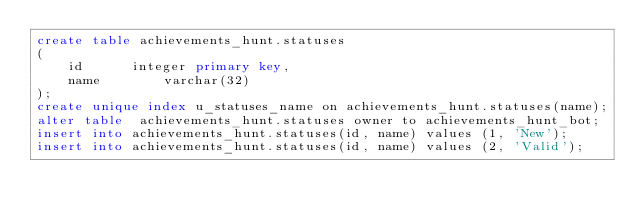<code> <loc_0><loc_0><loc_500><loc_500><_SQL_>create table achievements_hunt.statuses
(
    id 			integer primary key,
    name        varchar(32)
);
create unique index u_statuses_name on achievements_hunt.statuses(name);
alter table  achievements_hunt.statuses owner to achievements_hunt_bot;
insert into achievements_hunt.statuses(id, name) values (1, 'New');
insert into achievements_hunt.statuses(id, name) values (2, 'Valid');</code> 